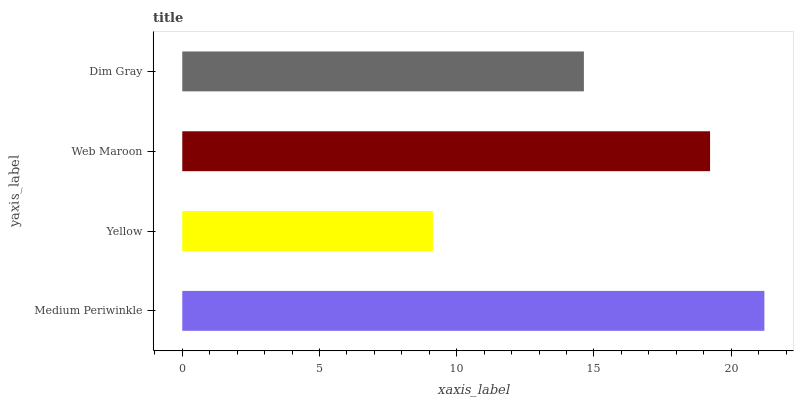Is Yellow the minimum?
Answer yes or no. Yes. Is Medium Periwinkle the maximum?
Answer yes or no. Yes. Is Web Maroon the minimum?
Answer yes or no. No. Is Web Maroon the maximum?
Answer yes or no. No. Is Web Maroon greater than Yellow?
Answer yes or no. Yes. Is Yellow less than Web Maroon?
Answer yes or no. Yes. Is Yellow greater than Web Maroon?
Answer yes or no. No. Is Web Maroon less than Yellow?
Answer yes or no. No. Is Web Maroon the high median?
Answer yes or no. Yes. Is Dim Gray the low median?
Answer yes or no. Yes. Is Yellow the high median?
Answer yes or no. No. Is Medium Periwinkle the low median?
Answer yes or no. No. 